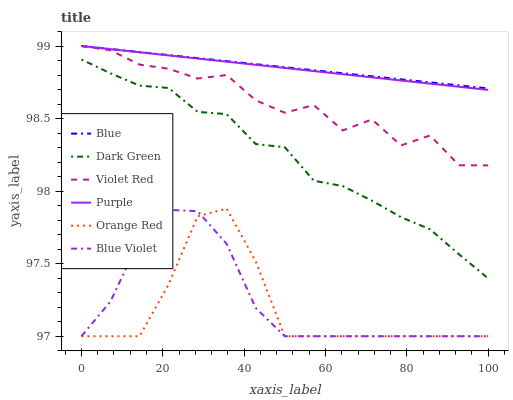Does Orange Red have the minimum area under the curve?
Answer yes or no. Yes. Does Blue have the maximum area under the curve?
Answer yes or no. Yes. Does Violet Red have the minimum area under the curve?
Answer yes or no. No. Does Violet Red have the maximum area under the curve?
Answer yes or no. No. Is Purple the smoothest?
Answer yes or no. Yes. Is Violet Red the roughest?
Answer yes or no. Yes. Is Violet Red the smoothest?
Answer yes or no. No. Is Purple the roughest?
Answer yes or no. No. Does Orange Red have the lowest value?
Answer yes or no. Yes. Does Violet Red have the lowest value?
Answer yes or no. No. Does Purple have the highest value?
Answer yes or no. Yes. Does Orange Red have the highest value?
Answer yes or no. No. Is Orange Red less than Dark Green?
Answer yes or no. Yes. Is Violet Red greater than Orange Red?
Answer yes or no. Yes. Does Blue intersect Violet Red?
Answer yes or no. Yes. Is Blue less than Violet Red?
Answer yes or no. No. Is Blue greater than Violet Red?
Answer yes or no. No. Does Orange Red intersect Dark Green?
Answer yes or no. No. 